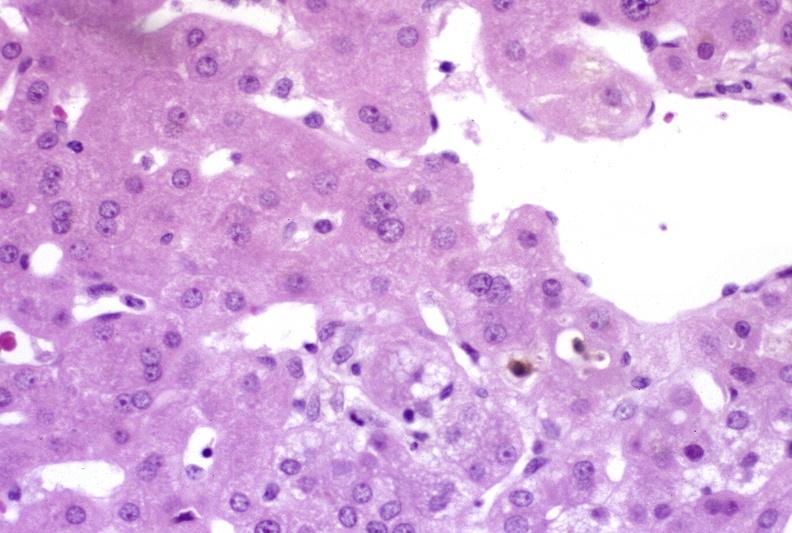s hepatobiliary present?
Answer the question using a single word or phrase. Yes 